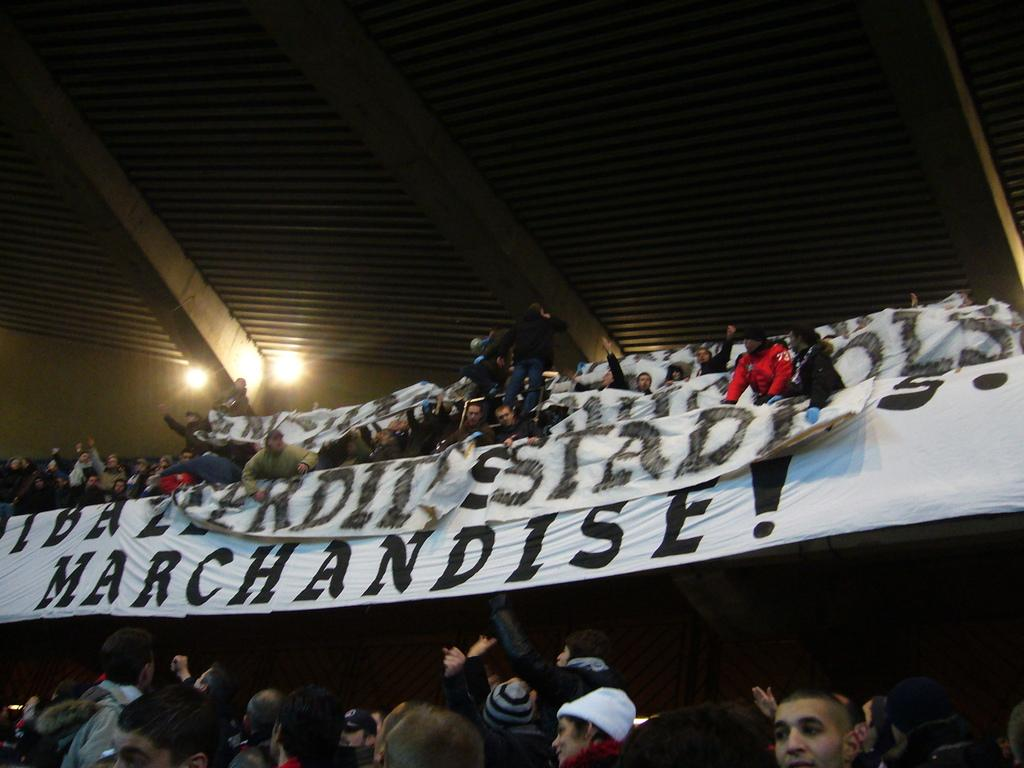What is the main subject of the image? The main subject of the image is a huge crowd. What can be seen in the hands of some people in the crowd? There are banners in the image. What is present above the crowd? There is a roof above the crowd in the image. What type of dinner is being served to the crowd in the image? There is no dinner being served in the image; it features a huge crowd with banners and a roof above them. What kind of produce can be seen growing in the image? There is no produce visible in the image. 